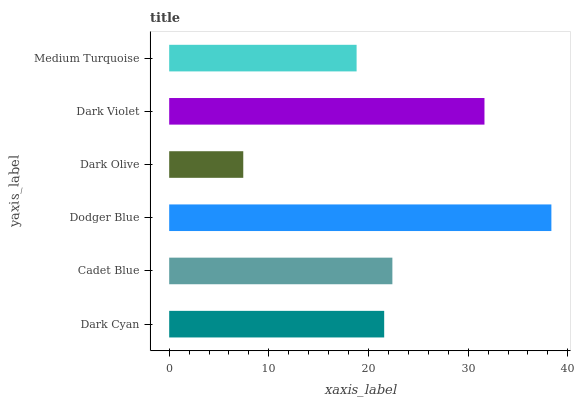Is Dark Olive the minimum?
Answer yes or no. Yes. Is Dodger Blue the maximum?
Answer yes or no. Yes. Is Cadet Blue the minimum?
Answer yes or no. No. Is Cadet Blue the maximum?
Answer yes or no. No. Is Cadet Blue greater than Dark Cyan?
Answer yes or no. Yes. Is Dark Cyan less than Cadet Blue?
Answer yes or no. Yes. Is Dark Cyan greater than Cadet Blue?
Answer yes or no. No. Is Cadet Blue less than Dark Cyan?
Answer yes or no. No. Is Cadet Blue the high median?
Answer yes or no. Yes. Is Dark Cyan the low median?
Answer yes or no. Yes. Is Medium Turquoise the high median?
Answer yes or no. No. Is Dark Olive the low median?
Answer yes or no. No. 